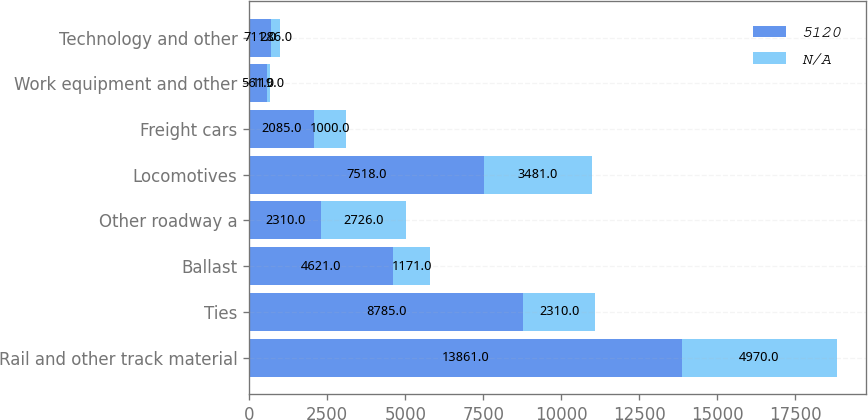Convert chart to OTSL. <chart><loc_0><loc_0><loc_500><loc_500><stacked_bar_chart><ecel><fcel>Rail and other track material<fcel>Ties<fcel>Ballast<fcel>Other roadway a<fcel>Locomotives<fcel>Freight cars<fcel>Work equipment and other<fcel>Technology and other<nl><fcel>5120<fcel>13861<fcel>8785<fcel>4621<fcel>2310<fcel>7518<fcel>2085<fcel>561<fcel>711<nl><fcel>nan<fcel>4970<fcel>2310<fcel>1171<fcel>2726<fcel>3481<fcel>1000<fcel>119<fcel>286<nl></chart> 